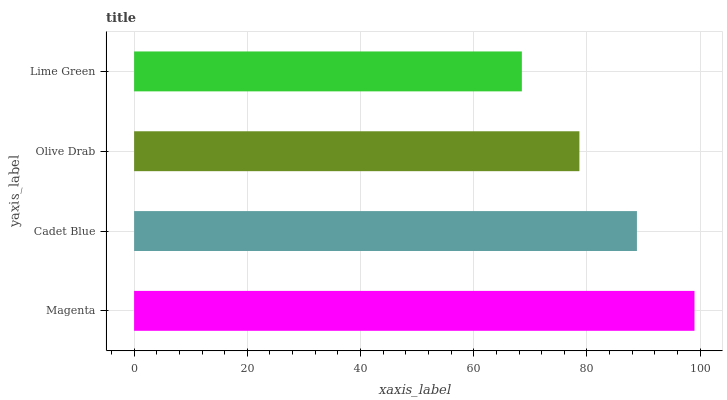Is Lime Green the minimum?
Answer yes or no. Yes. Is Magenta the maximum?
Answer yes or no. Yes. Is Cadet Blue the minimum?
Answer yes or no. No. Is Cadet Blue the maximum?
Answer yes or no. No. Is Magenta greater than Cadet Blue?
Answer yes or no. Yes. Is Cadet Blue less than Magenta?
Answer yes or no. Yes. Is Cadet Blue greater than Magenta?
Answer yes or no. No. Is Magenta less than Cadet Blue?
Answer yes or no. No. Is Cadet Blue the high median?
Answer yes or no. Yes. Is Olive Drab the low median?
Answer yes or no. Yes. Is Lime Green the high median?
Answer yes or no. No. Is Cadet Blue the low median?
Answer yes or no. No. 